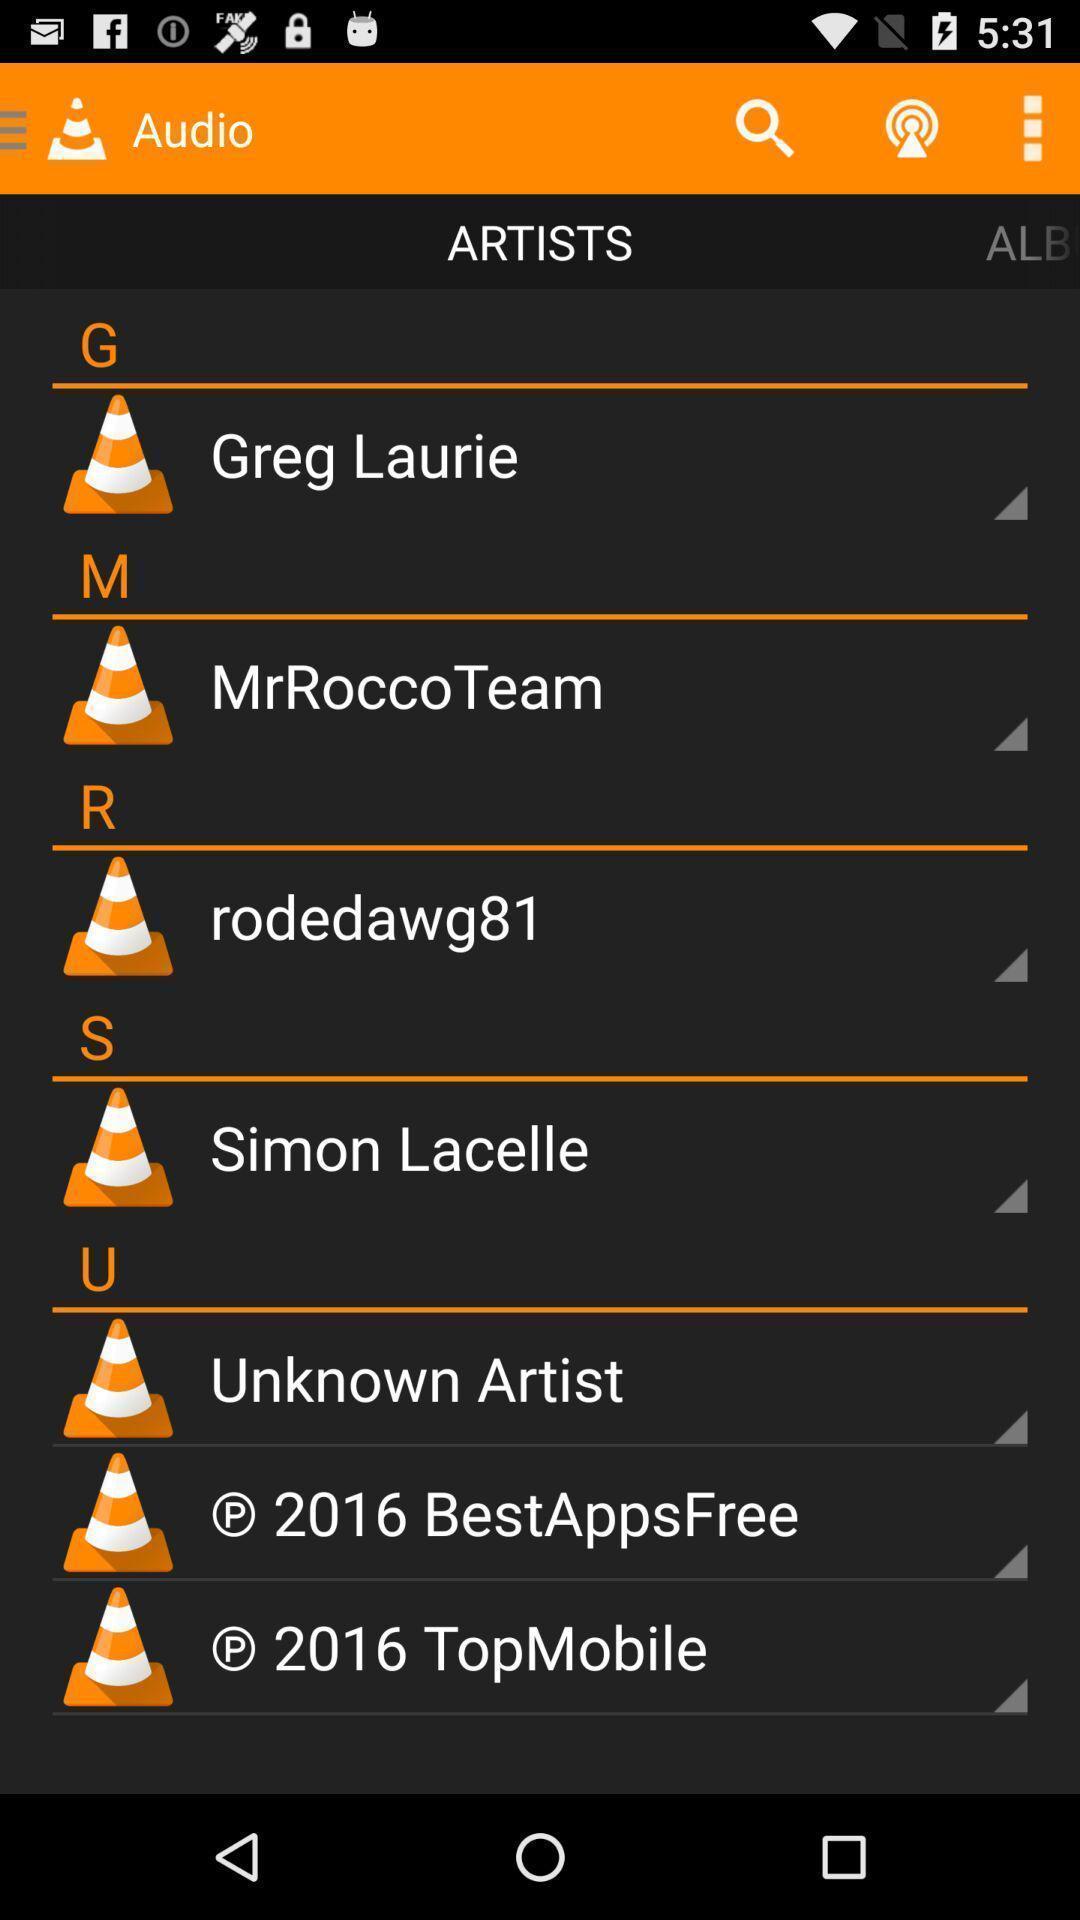Tell me what you see in this picture. Screen shows artists page in video player application. 